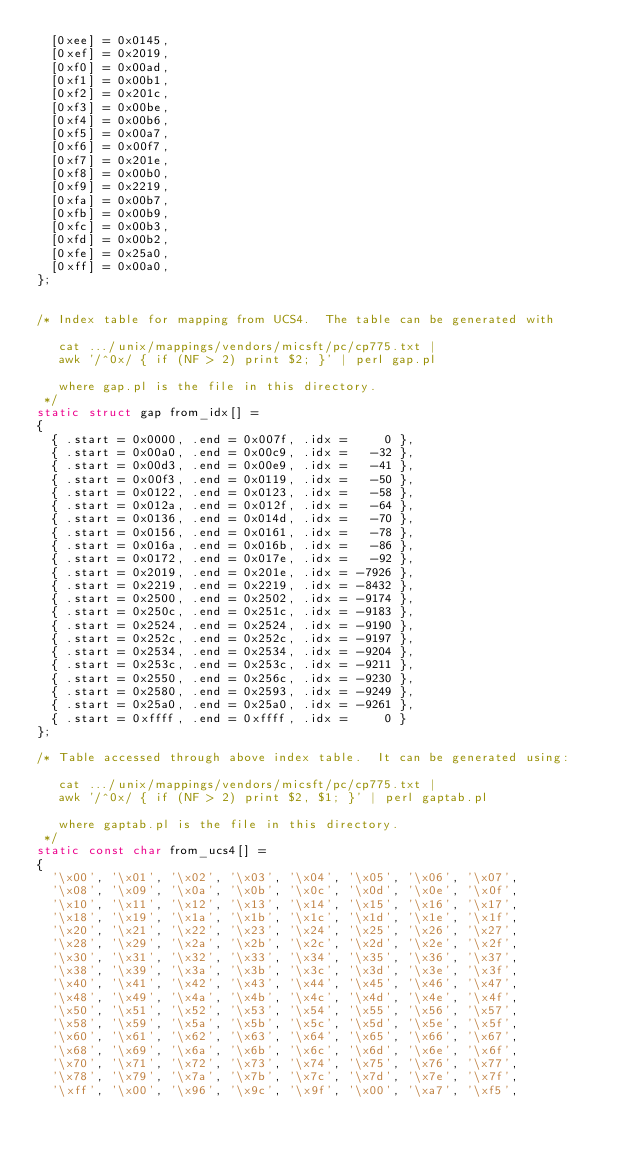<code> <loc_0><loc_0><loc_500><loc_500><_C_>  [0xee] = 0x0145,
  [0xef] = 0x2019,
  [0xf0] = 0x00ad,
  [0xf1] = 0x00b1,
  [0xf2] = 0x201c,
  [0xf3] = 0x00be,
  [0xf4] = 0x00b6,
  [0xf5] = 0x00a7,
  [0xf6] = 0x00f7,
  [0xf7] = 0x201e,
  [0xf8] = 0x00b0,
  [0xf9] = 0x2219,
  [0xfa] = 0x00b7,
  [0xfb] = 0x00b9,
  [0xfc] = 0x00b3,
  [0xfd] = 0x00b2,
  [0xfe] = 0x25a0,
  [0xff] = 0x00a0,
};


/* Index table for mapping from UCS4.  The table can be generated with

   cat .../unix/mappings/vendors/micsft/pc/cp775.txt |
   awk '/^0x/ { if (NF > 2) print $2; }' | perl gap.pl

   where gap.pl is the file in this directory.
 */
static struct gap from_idx[] =
{
  { .start = 0x0000, .end = 0x007f, .idx =     0 },
  { .start = 0x00a0, .end = 0x00c9, .idx =   -32 },
  { .start = 0x00d3, .end = 0x00e9, .idx =   -41 },
  { .start = 0x00f3, .end = 0x0119, .idx =   -50 },
  { .start = 0x0122, .end = 0x0123, .idx =   -58 },
  { .start = 0x012a, .end = 0x012f, .idx =   -64 },
  { .start = 0x0136, .end = 0x014d, .idx =   -70 },
  { .start = 0x0156, .end = 0x0161, .idx =   -78 },
  { .start = 0x016a, .end = 0x016b, .idx =   -86 },
  { .start = 0x0172, .end = 0x017e, .idx =   -92 },
  { .start = 0x2019, .end = 0x201e, .idx = -7926 },
  { .start = 0x2219, .end = 0x2219, .idx = -8432 },
  { .start = 0x2500, .end = 0x2502, .idx = -9174 },
  { .start = 0x250c, .end = 0x251c, .idx = -9183 },
  { .start = 0x2524, .end = 0x2524, .idx = -9190 },
  { .start = 0x252c, .end = 0x252c, .idx = -9197 },
  { .start = 0x2534, .end = 0x2534, .idx = -9204 },
  { .start = 0x253c, .end = 0x253c, .idx = -9211 },
  { .start = 0x2550, .end = 0x256c, .idx = -9230 },
  { .start = 0x2580, .end = 0x2593, .idx = -9249 },
  { .start = 0x25a0, .end = 0x25a0, .idx = -9261 },
  { .start = 0xffff, .end = 0xffff, .idx =     0 }
};

/* Table accessed through above index table.  It can be generated using:

   cat .../unix/mappings/vendors/micsft/pc/cp775.txt |
   awk '/^0x/ { if (NF > 2) print $2, $1; }' | perl gaptab.pl

   where gaptab.pl is the file in this directory.
 */
static const char from_ucs4[] =
{
  '\x00', '\x01', '\x02', '\x03', '\x04', '\x05', '\x06', '\x07',
  '\x08', '\x09', '\x0a', '\x0b', '\x0c', '\x0d', '\x0e', '\x0f',
  '\x10', '\x11', '\x12', '\x13', '\x14', '\x15', '\x16', '\x17',
  '\x18', '\x19', '\x1a', '\x1b', '\x1c', '\x1d', '\x1e', '\x1f',
  '\x20', '\x21', '\x22', '\x23', '\x24', '\x25', '\x26', '\x27',
  '\x28', '\x29', '\x2a', '\x2b', '\x2c', '\x2d', '\x2e', '\x2f',
  '\x30', '\x31', '\x32', '\x33', '\x34', '\x35', '\x36', '\x37',
  '\x38', '\x39', '\x3a', '\x3b', '\x3c', '\x3d', '\x3e', '\x3f',
  '\x40', '\x41', '\x42', '\x43', '\x44', '\x45', '\x46', '\x47',
  '\x48', '\x49', '\x4a', '\x4b', '\x4c', '\x4d', '\x4e', '\x4f',
  '\x50', '\x51', '\x52', '\x53', '\x54', '\x55', '\x56', '\x57',
  '\x58', '\x59', '\x5a', '\x5b', '\x5c', '\x5d', '\x5e', '\x5f',
  '\x60', '\x61', '\x62', '\x63', '\x64', '\x65', '\x66', '\x67',
  '\x68', '\x69', '\x6a', '\x6b', '\x6c', '\x6d', '\x6e', '\x6f',
  '\x70', '\x71', '\x72', '\x73', '\x74', '\x75', '\x76', '\x77',
  '\x78', '\x79', '\x7a', '\x7b', '\x7c', '\x7d', '\x7e', '\x7f',
  '\xff', '\x00', '\x96', '\x9c', '\x9f', '\x00', '\xa7', '\xf5',</code> 